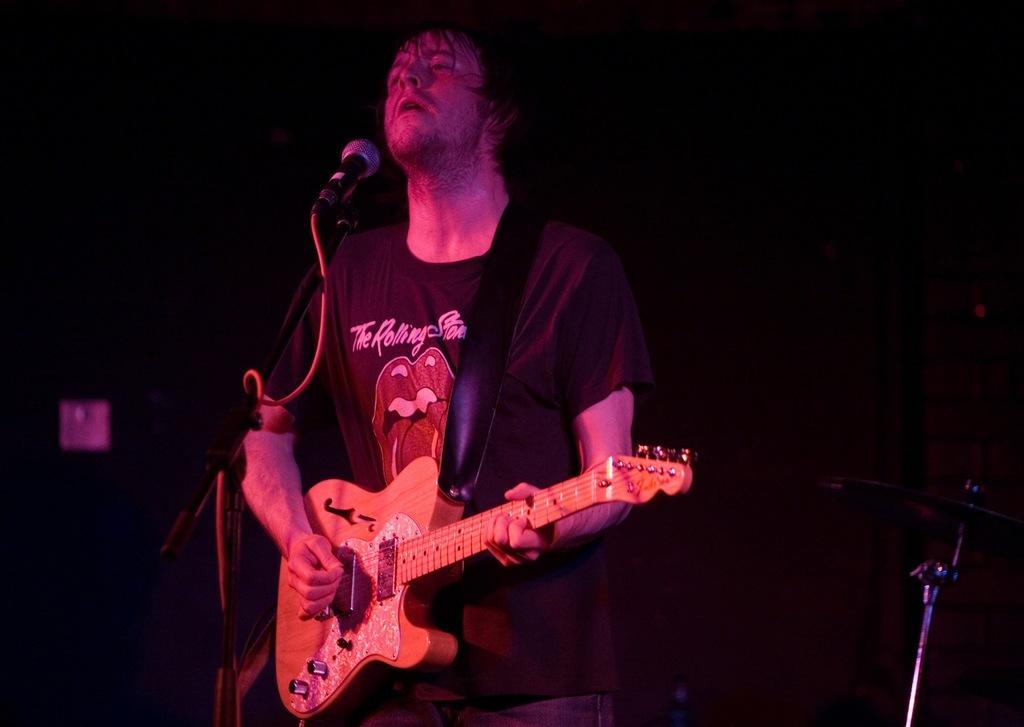Could you give a brief overview of what you see in this image? In this image I can see a person standing in-front of the mic and holding the guitar. 